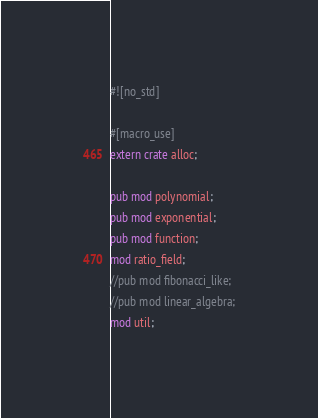<code> <loc_0><loc_0><loc_500><loc_500><_Rust_>#![no_std]

#[macro_use]
extern crate alloc;

pub mod polynomial;
pub mod exponential;
pub mod function;
mod ratio_field;
//pub mod fibonacci_like;
//pub mod linear_algebra;
mod util;</code> 